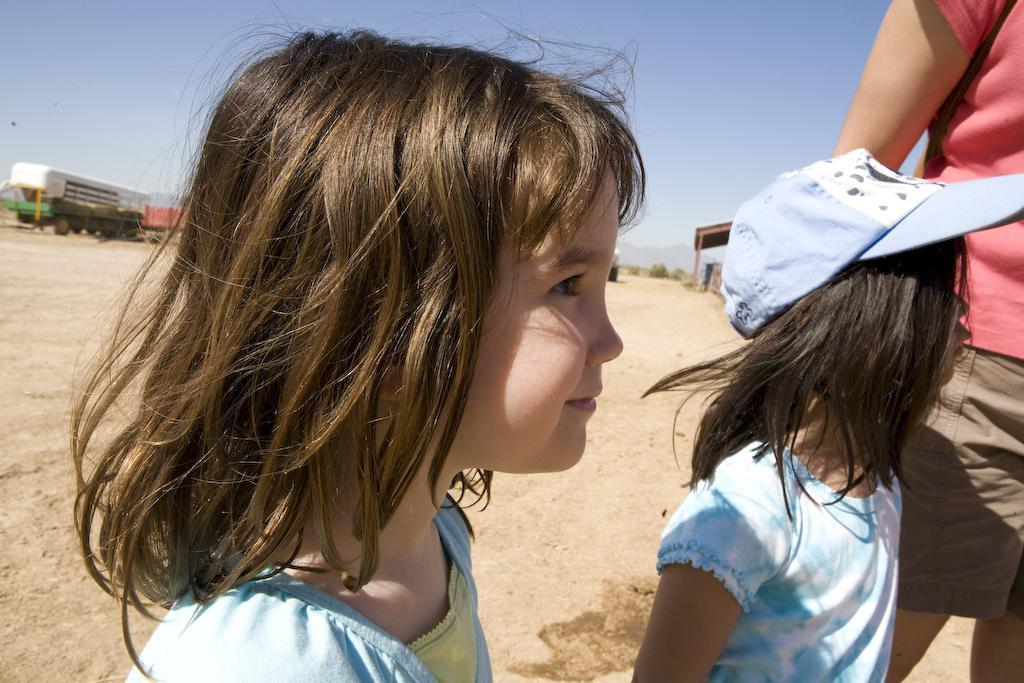Who or what can be seen in the image? There are people in the image. What can be seen in the distance behind the people? There is a vehicle, trees, hills, and the sky visible in the background of the image. What type of bread is being used to pay the tax in the image? There is no bread or tax mentioned or depicted in the image. 